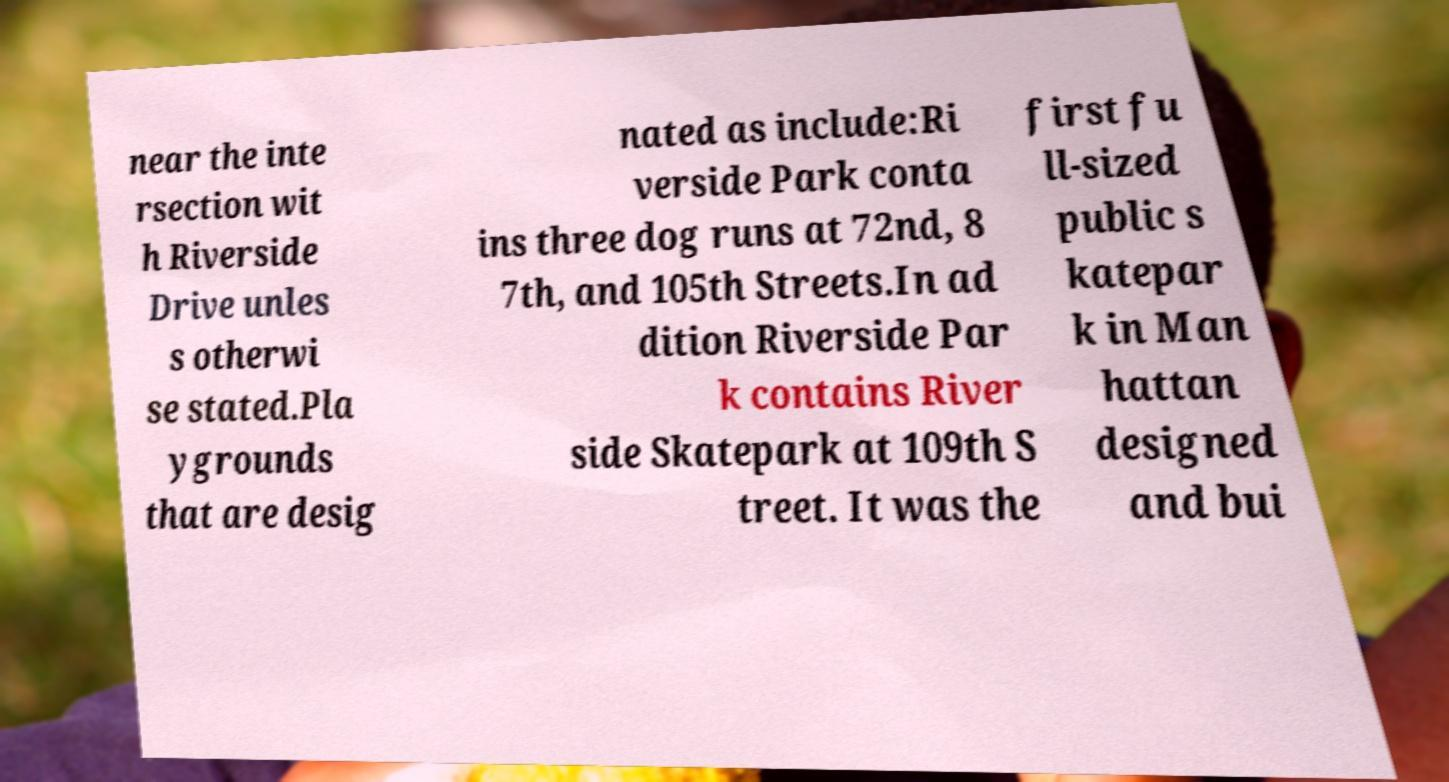Can you accurately transcribe the text from the provided image for me? near the inte rsection wit h Riverside Drive unles s otherwi se stated.Pla ygrounds that are desig nated as include:Ri verside Park conta ins three dog runs at 72nd, 8 7th, and 105th Streets.In ad dition Riverside Par k contains River side Skatepark at 109th S treet. It was the first fu ll-sized public s katepar k in Man hattan designed and bui 